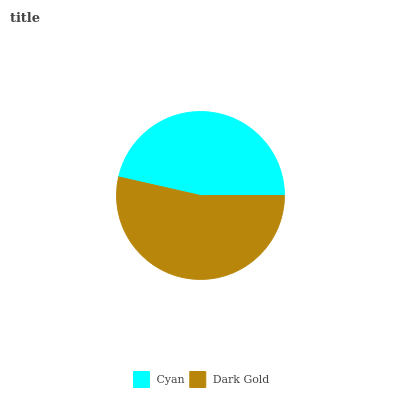Is Cyan the minimum?
Answer yes or no. Yes. Is Dark Gold the maximum?
Answer yes or no. Yes. Is Dark Gold the minimum?
Answer yes or no. No. Is Dark Gold greater than Cyan?
Answer yes or no. Yes. Is Cyan less than Dark Gold?
Answer yes or no. Yes. Is Cyan greater than Dark Gold?
Answer yes or no. No. Is Dark Gold less than Cyan?
Answer yes or no. No. Is Dark Gold the high median?
Answer yes or no. Yes. Is Cyan the low median?
Answer yes or no. Yes. Is Cyan the high median?
Answer yes or no. No. Is Dark Gold the low median?
Answer yes or no. No. 